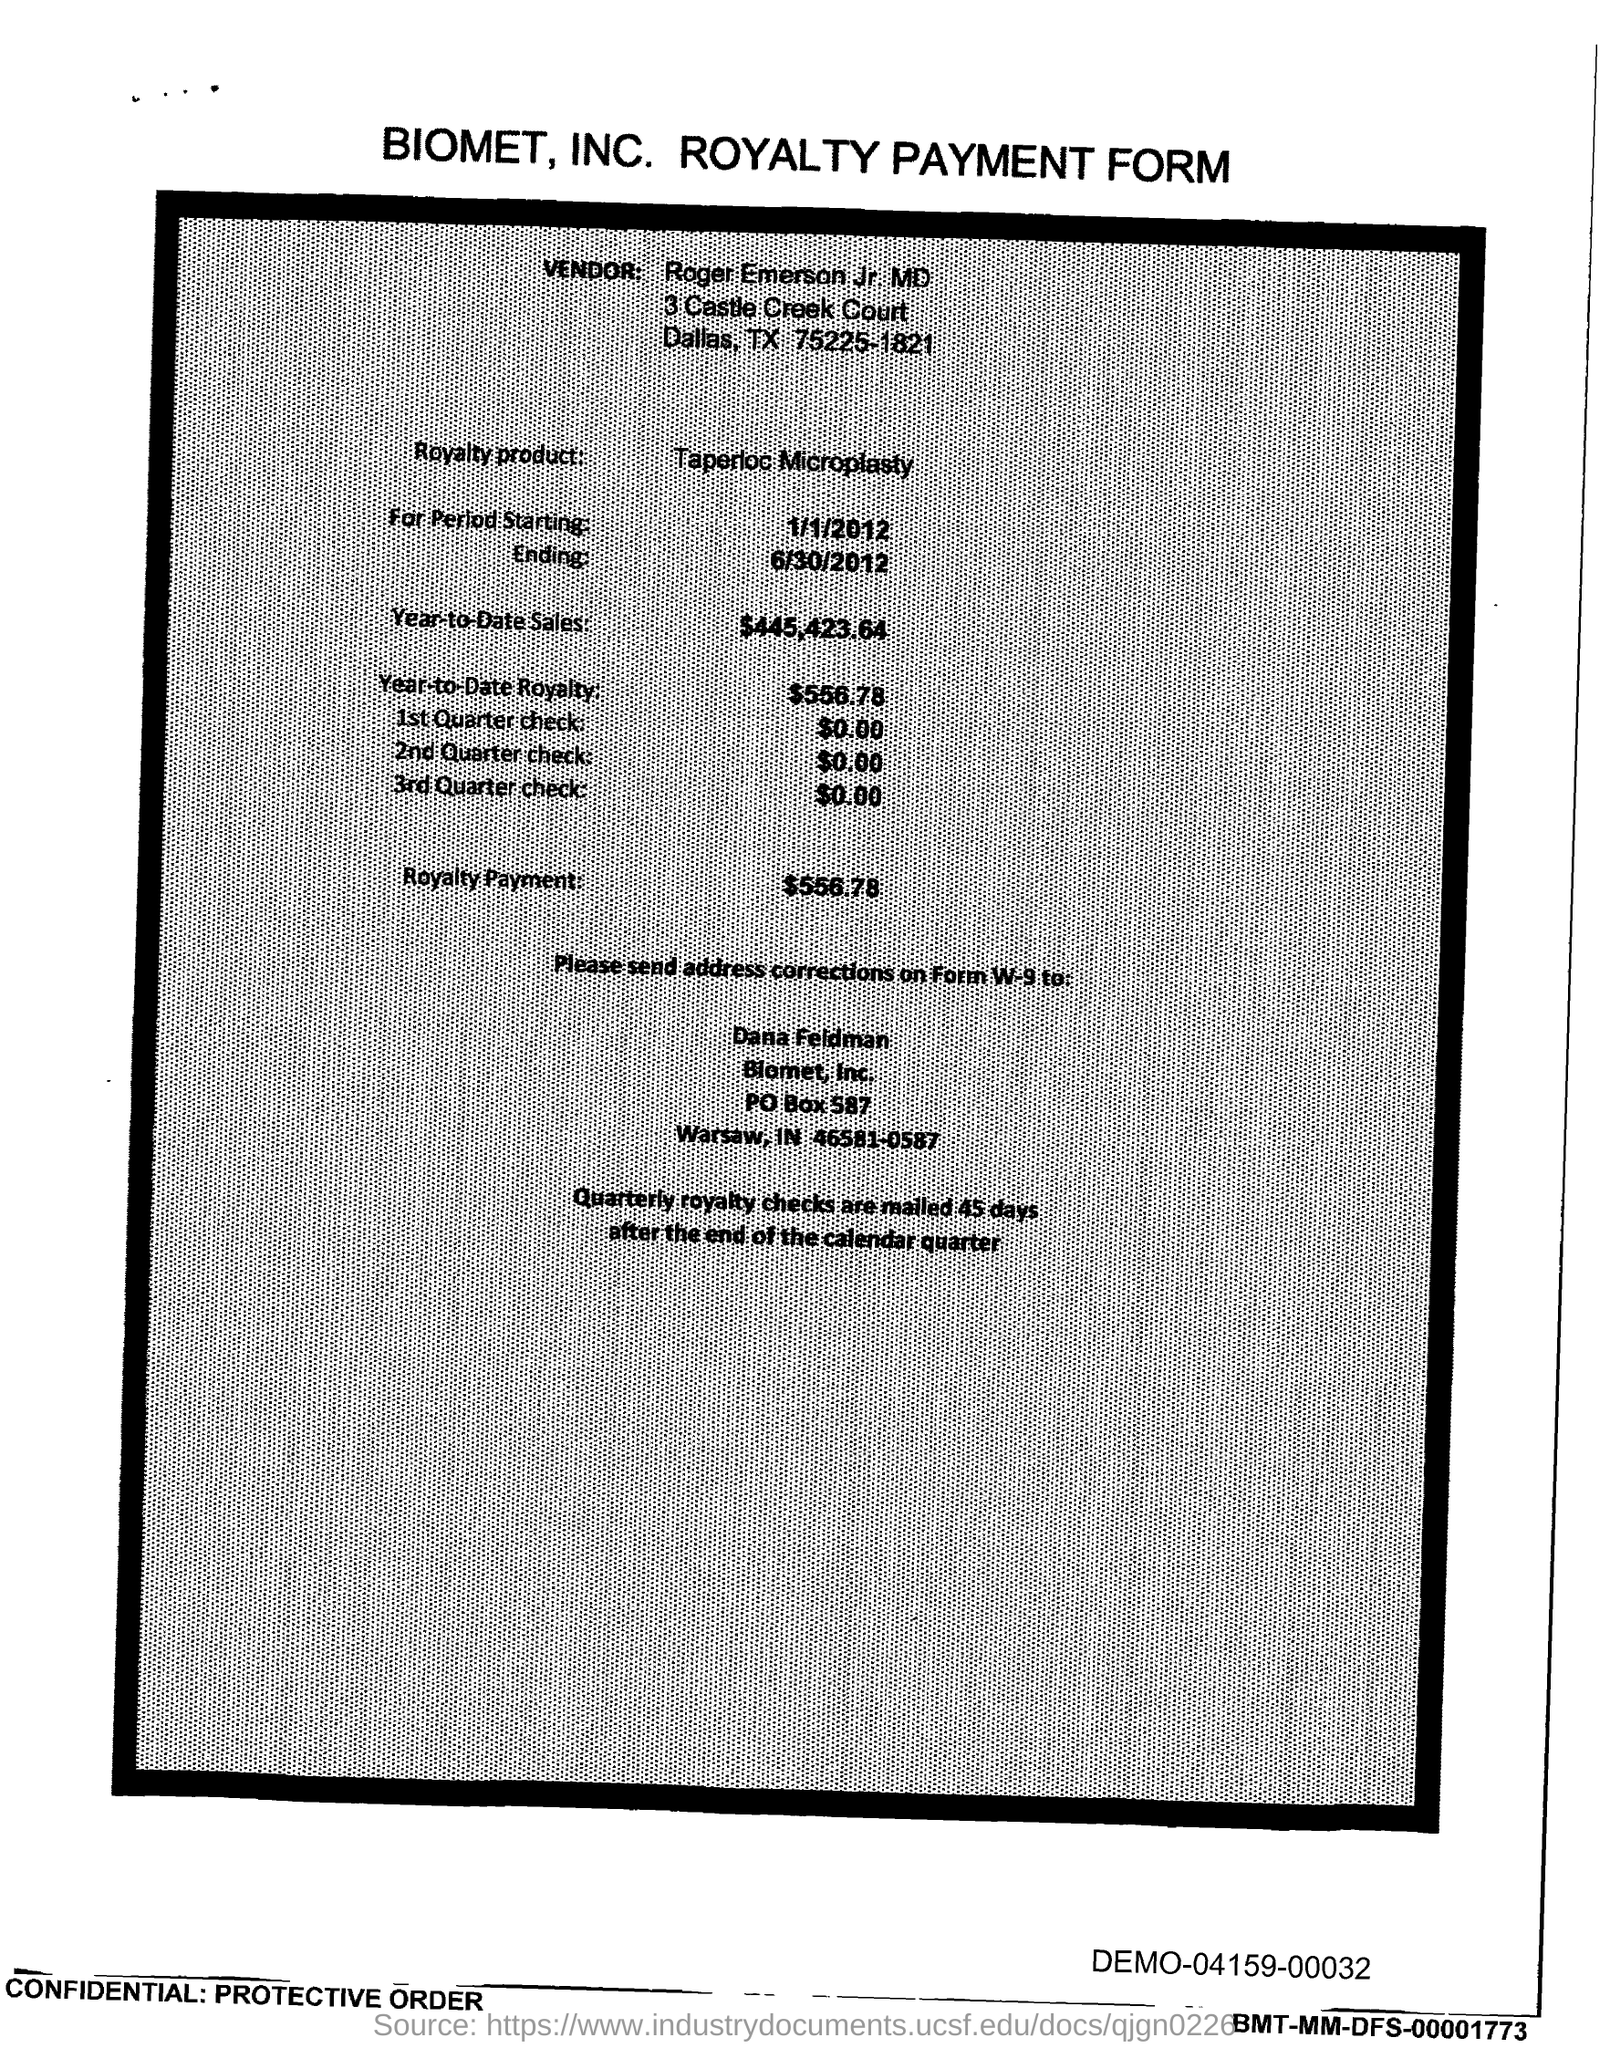Indicate a few pertinent items in this graphic. The ending period mentioned is 6/30/2012. The year-to-date royalty has reached $556.78. Roger Emerson Jr. is the vendor. The year-to-date sales as of now are 445,423.64. Introducing Taperloc Microplasty, a revolutionary solution for joint pain caused by osteoarthritis. Taperloc Microplasty is a minimally invasive procedure that involves the use of a specialized tapered needle to deliver a small amount of cement to the affected joint, alleviating pain and restoring mobility. 